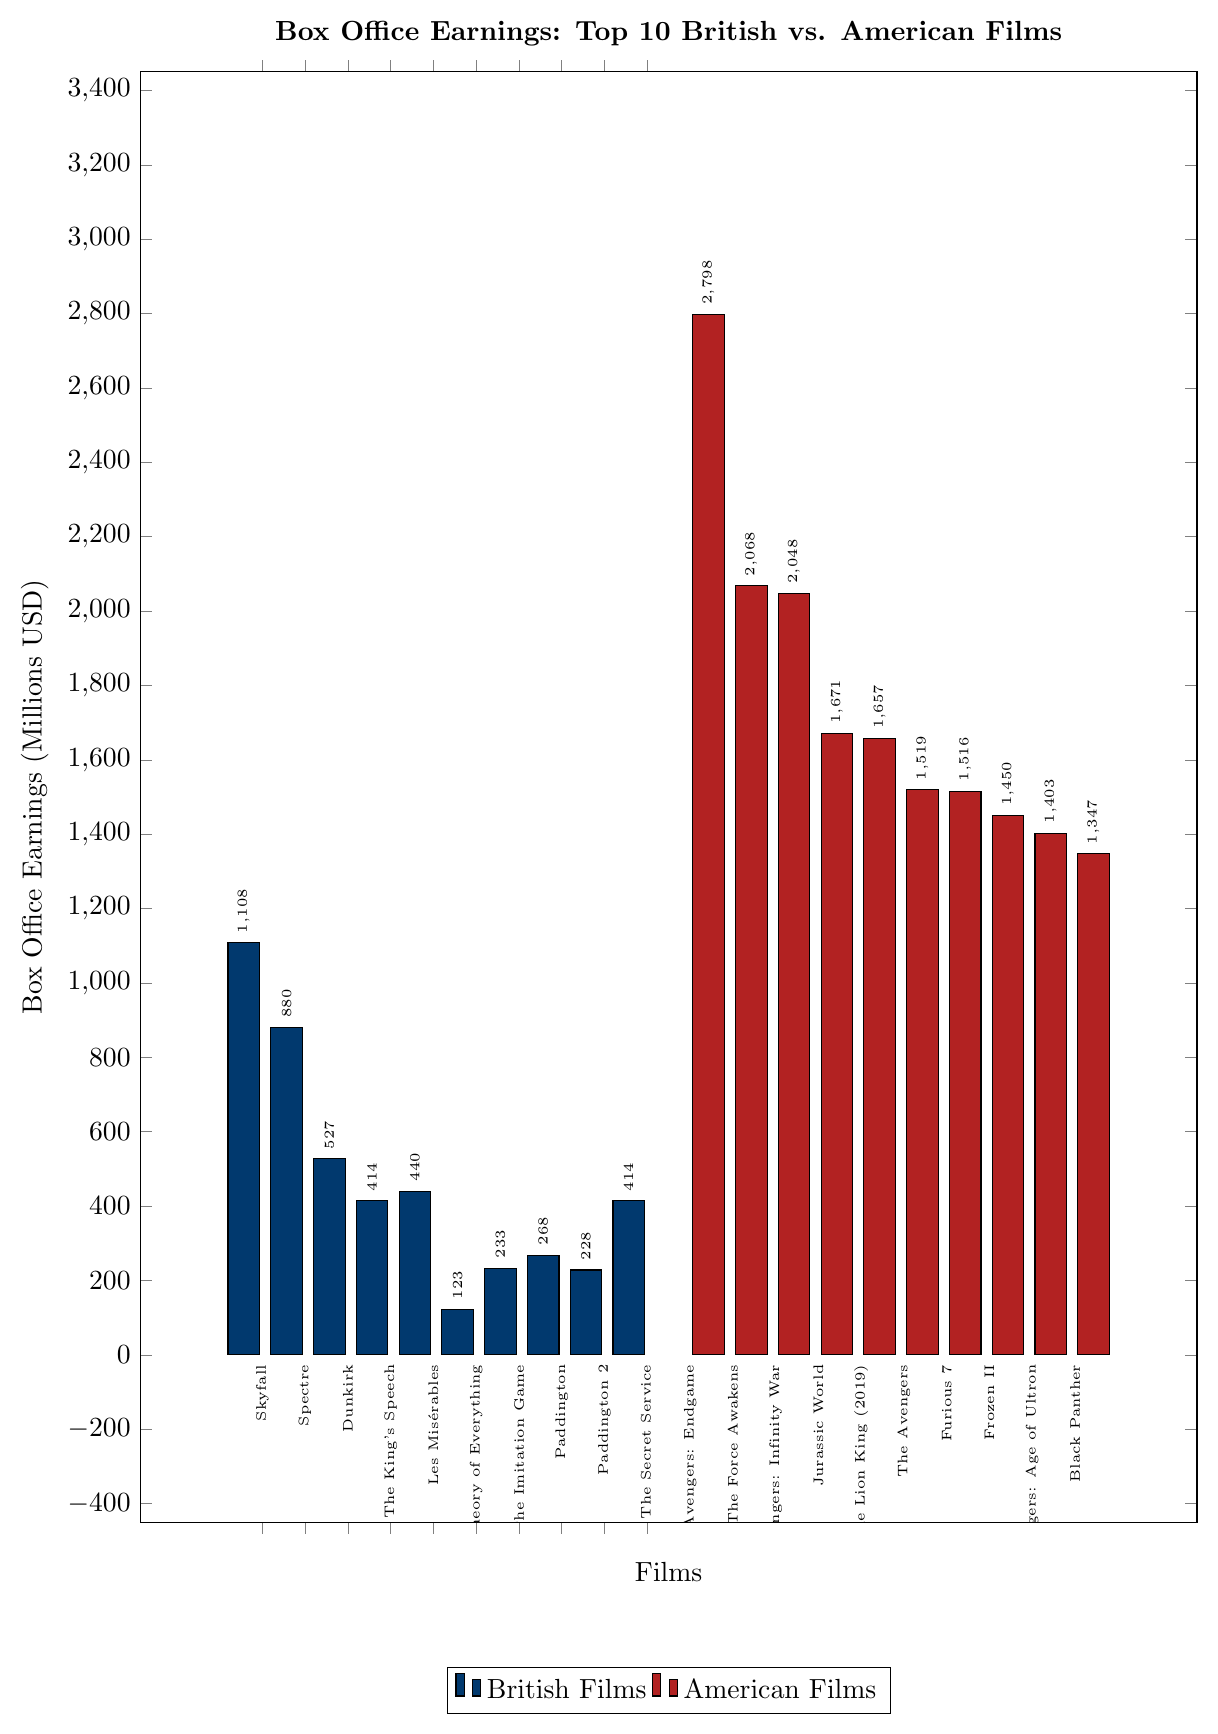What is the highest box office earning among the British films? The highest box office earning among the British films can be identified by comparing the heights of the blue bars. "Skyfall" has the tallest bar with earnings of 1108 million USD.
Answer: 1108 million USD How many British films earned more than 400 million USD? To count the British films that earned more than 400 million USD, observe the blue bars that are taller than the 400 million USD mark on the y-axis. The films "Skyfall," "Spectre," "Dunkirk," and "Kingsman: The Secret Service" meet this criterion.
Answer: 4 How much more did Avengers: Endgame earn compared to Skyfall? First, find the box office earnings for both films: "Avengers: Endgame" (2798 million USD) and "Skyfall" (1108 million USD). Then, subtract the earnings of "Skyfall" from "Avengers: Endgame": 2798 - 1108 = 1690 million USD.
Answer: 1690 million USD What is the combined box office earnings of the top 3 British films? Identify the top 3 British films with the highest earnings: "Skyfall" (1108 million USD), "Spectre" (880 million USD), and "Dunkirk" (527 million USD). Add these numbers together: 1108 + 880 + 527 = 2515 million USD.
Answer: 2515 million USD Which film earned more, The Lion King (2019) or The Avengers? Compare the heights of the bars for "The Lion King (2019)" (1657 million USD) and "The Avengers" (1519 million USD). "The Lion King (2019)" has higher earnings.
Answer: The Lion King (2019) What is the total box office earnings for all American films combined? Sum up the box office earnings of all American films: 2798 + 2068 + 2048 + 1671 + 1657 + 1519 + 1516 + 1450 + 1403 + 1347 = 17477 million USD.
Answer: 17477 million USD Which country's films dominate the top half of the earnings chart? Observing the highest earnings bars, all the films in the top half (10 films) belong to the American category, indicated by the red color.
Answer: American What is the difference in earnings between the lowest-grossing British film and the lowest-grossing American film? Identify the lowest-grossing British film ("The Theory of Everything" with 123 million USD) and the lowest-grossing American film ("Black Panther" with 1347 million USD). Calculate the difference: 1347 - 123 = 1224 million USD.
Answer: 1224 million USD How many American films earned over 1500 million USD? Count the red bars taller than the 1500 million USD mark. The films are "Avengers: Endgame," "Star Wars: The Force Awakens," "Avengers: Infinity War," "Jurassic World," "The Lion King (2019)," "The Avengers," and "Furious 7".
Answer: 7 